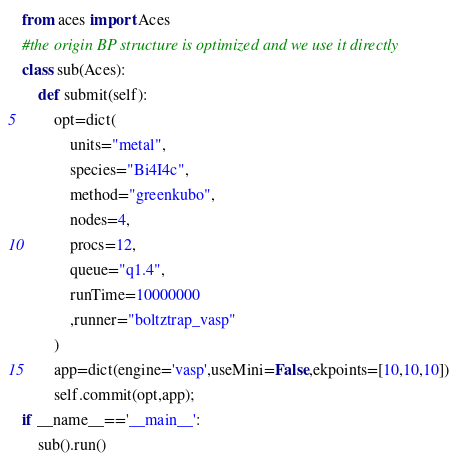Convert code to text. <code><loc_0><loc_0><loc_500><loc_500><_Python_>from aces import Aces
#the origin BP structure is optimized and we use it directly
class sub(Aces):
	def submit(self):
		opt=dict(
			units="metal",
			species="Bi4I4c",
			method="greenkubo",
			nodes=4,
			procs=12,
			queue="q1.4",
			runTime=10000000
			,runner="boltztrap_vasp"
		)
		app=dict(engine='vasp',useMini=False,ekpoints=[10,10,10])
		self.commit(opt,app);
if __name__=='__main__':
	sub().run()
</code> 